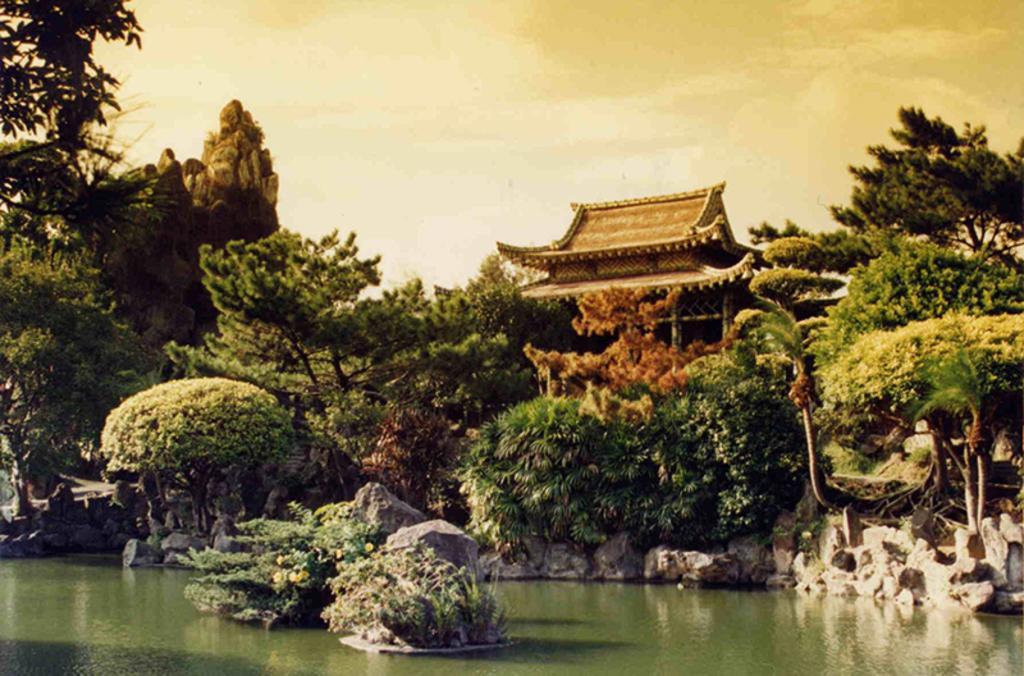In one or two sentences, can you explain what this image depicts? This is an image of the painting where we can see there is a lake and plants beside that, also there is a shed.. 